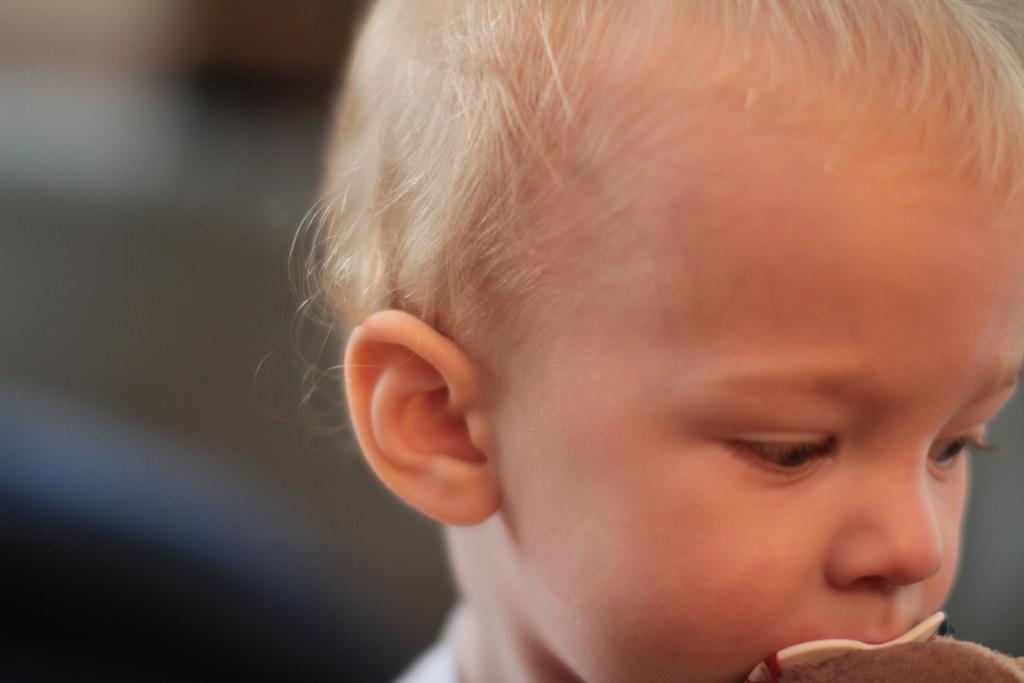What is located on the right side of the image? There is a person and other objects on the right side of the image. Can you describe the person in the image? The provided facts do not give any details about the person's appearance or actions. What can be observed about the background of the image? The background of the image is blurry. What type of wall can be seen in the image? There is no wall present in the image. How many seeds are visible in the image? There are no seeds present in the image. 